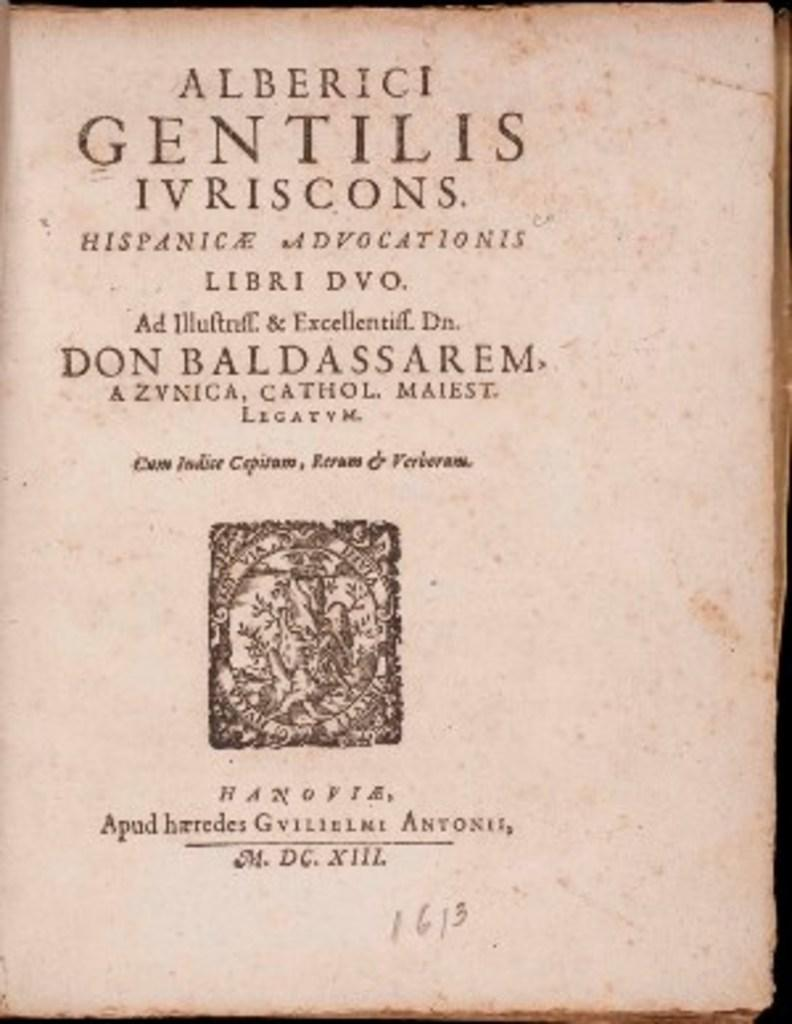<image>
Summarize the visual content of the image. A book with the words Alberici Gentilis Ivriscons. Hispanica Advocationis sits on a table. 